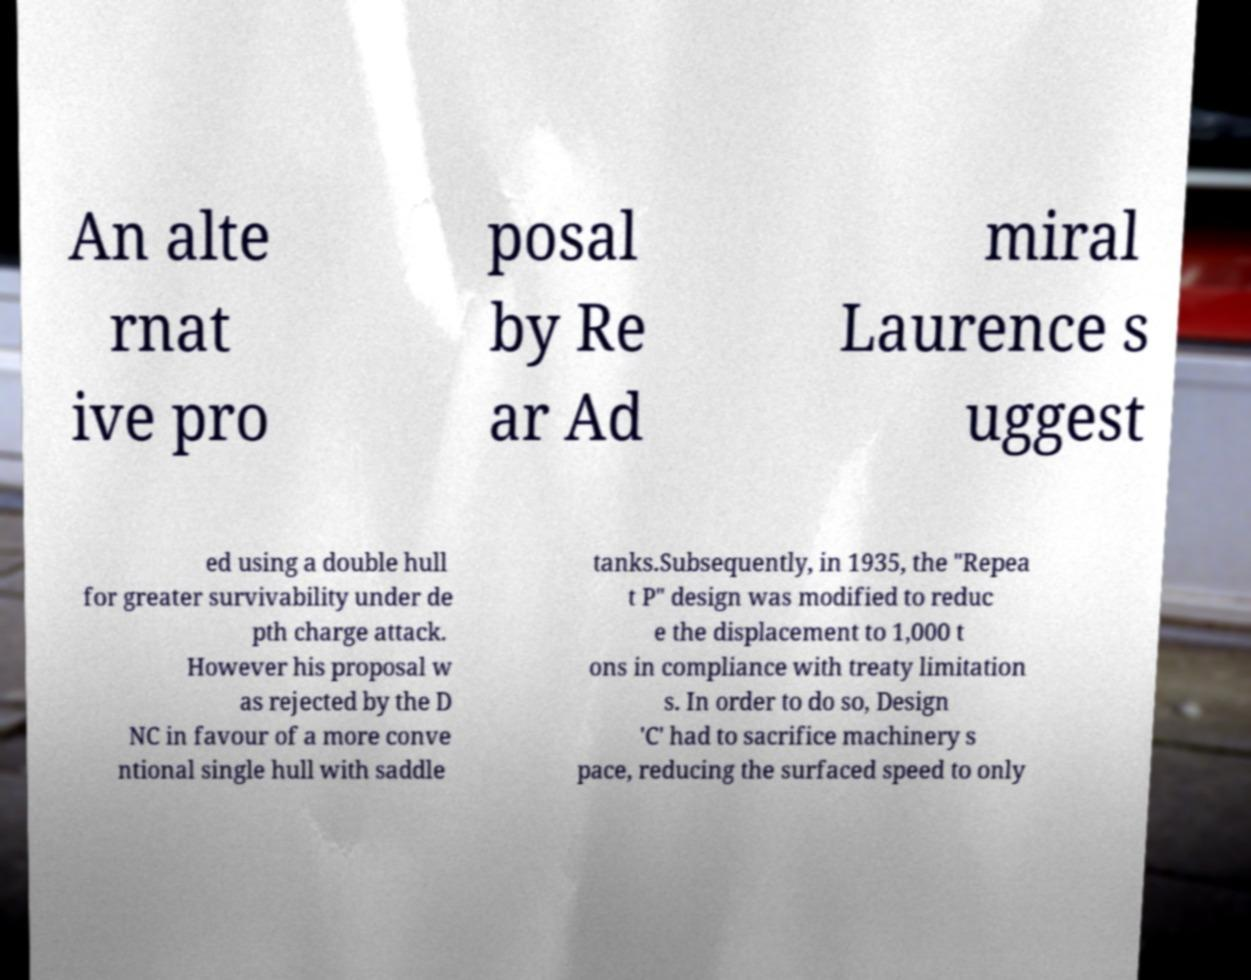Could you extract and type out the text from this image? An alte rnat ive pro posal by Re ar Ad miral Laurence s uggest ed using a double hull for greater survivability under de pth charge attack. However his proposal w as rejected by the D NC in favour of a more conve ntional single hull with saddle tanks.Subsequently, in 1935, the "Repea t P" design was modified to reduc e the displacement to 1,000 t ons in compliance with treaty limitation s. In order to do so, Design 'C' had to sacrifice machinery s pace, reducing the surfaced speed to only 